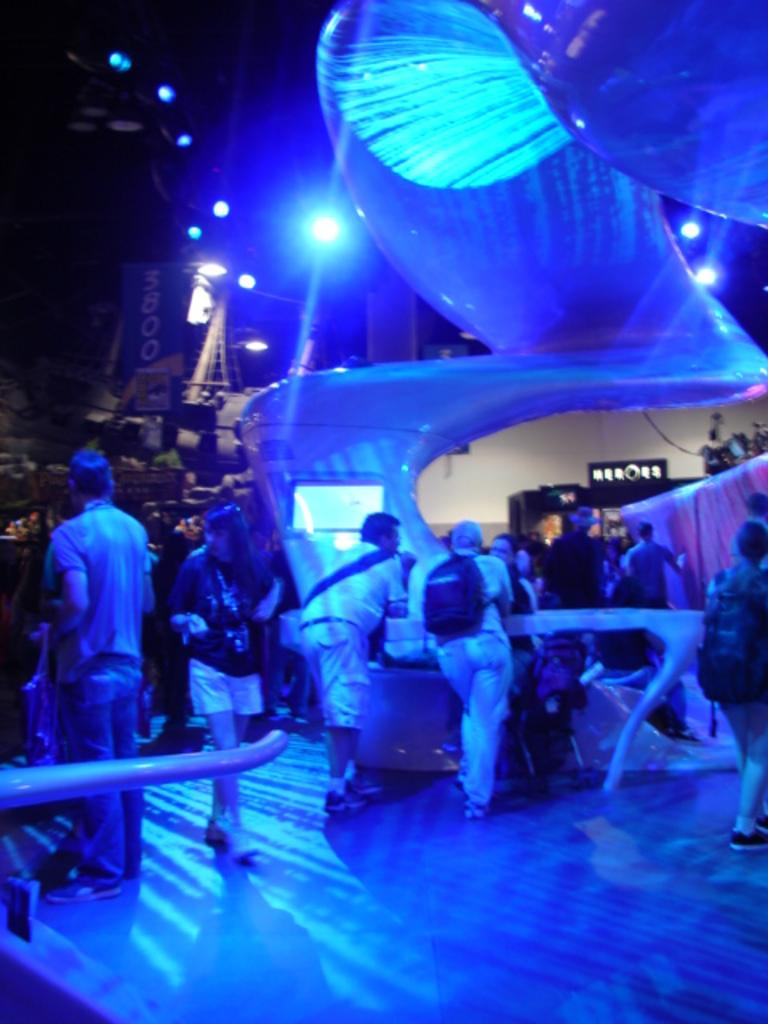How many people are in the image? There are people in the image, but the exact number is not specified. What are some of the people doing in the image? Some people are standing, and some people are walking. What is the source of illumination in the image? The image is illuminated by blue lights. How many times has the yoke been copied in the image? There is no mention of a yoke in the image, so it cannot be copied or counted. 